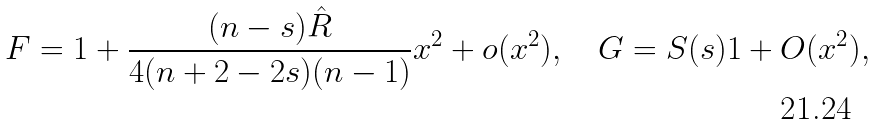<formula> <loc_0><loc_0><loc_500><loc_500>F = 1 + \frac { ( n - s ) \hat { R } } { 4 ( n + 2 - 2 s ) ( n - 1 ) } x ^ { 2 } + o ( x ^ { 2 } ) , \quad G = S ( s ) 1 + O ( x ^ { 2 } ) ,</formula> 